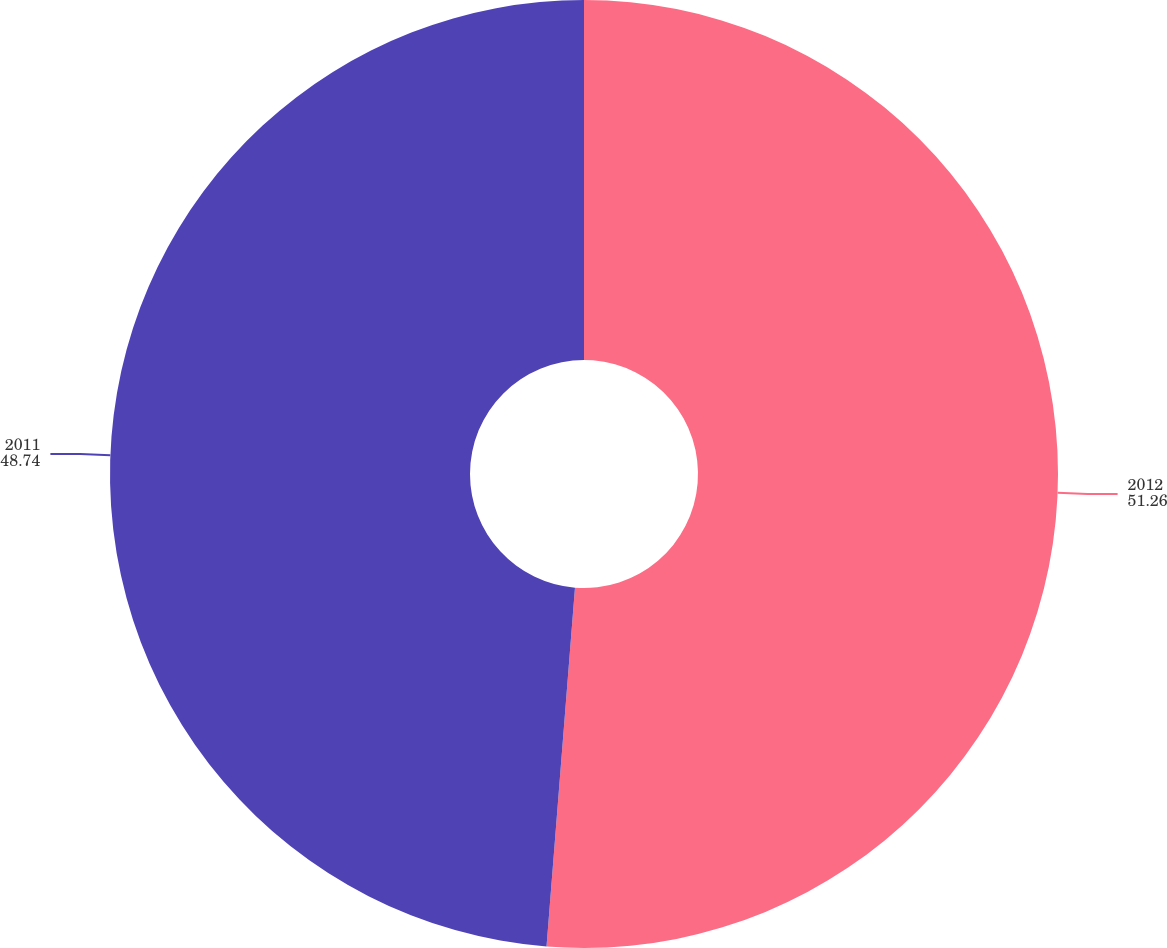Convert chart. <chart><loc_0><loc_0><loc_500><loc_500><pie_chart><fcel>2012<fcel>2011<nl><fcel>51.26%<fcel>48.74%<nl></chart> 